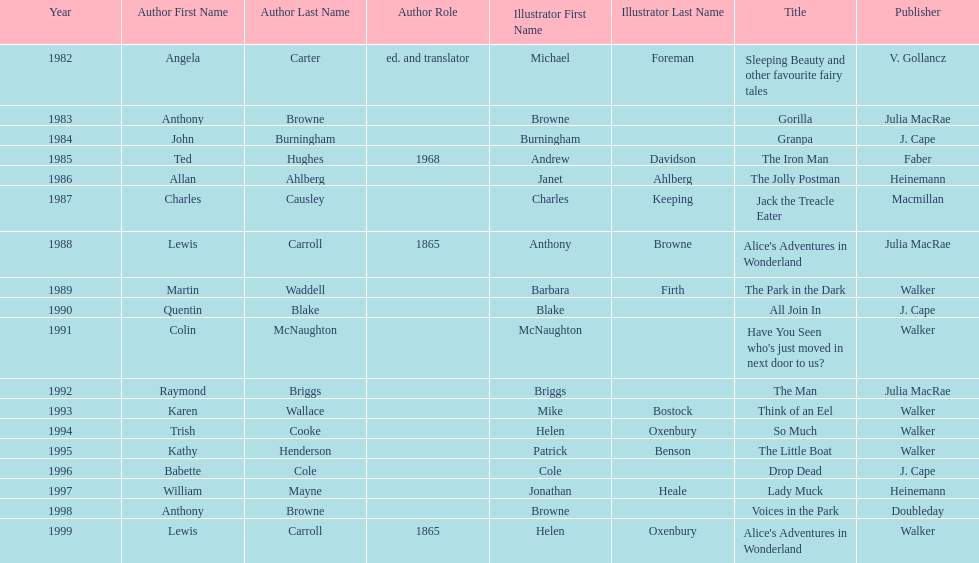Which illustrator was responsible for the last award winner? Helen Oxenbury. 